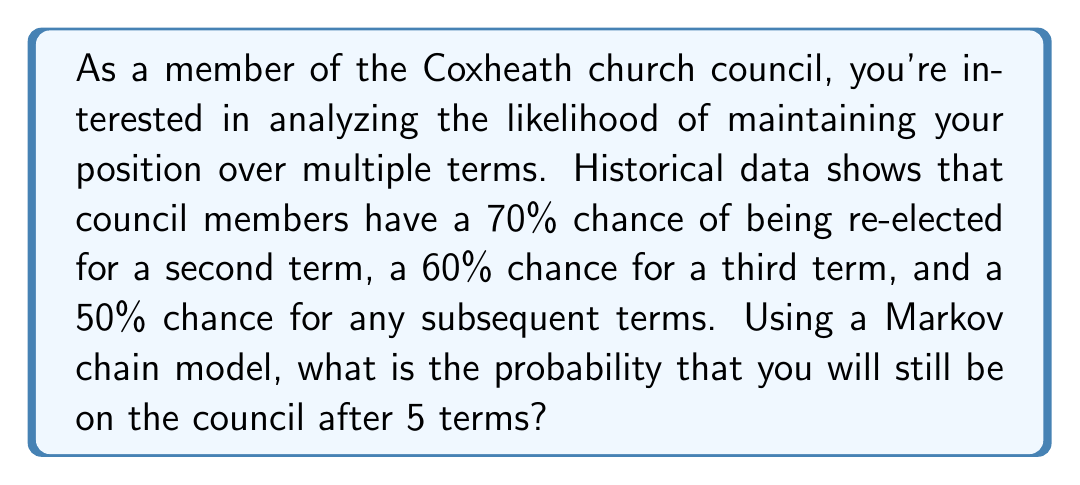Give your solution to this math problem. Let's approach this step-by-step using a Markov chain:

1) First, let's define our states:
   State 1: On the council
   State 2: Off the council (absorbing state)

2) We can represent our Markov chain with the following transition matrix:

   $$P = \begin{bmatrix}
   p_{11} & p_{12} \\
   0 & 1
   \end{bmatrix}$$

   Where $p_{11}$ is the probability of staying on the council, and $p_{12}$ is the probability of leaving the council.

3) Given the information:
   - For the 1st to 2nd term: $p_{11} = 0.7$, $p_{12} = 0.3$
   - For the 2nd to 3rd term: $p_{11} = 0.6$, $p_{12} = 0.4$
   - For subsequent terms: $p_{11} = 0.5$, $p_{12} = 0.5$

4) To calculate the probability of being on the council after 5 terms, we need to multiply these probabilities:

   $$P(\text{on council after 5 terms}) = 0.7 \times 0.6 \times 0.5 \times 0.5 \times 0.5$$

5) Let's calculate:
   $$0.7 \times 0.6 = 0.42$$
   $$0.42 \times 0.5 = 0.21$$
   $$0.21 \times 0.5 = 0.105$$
   $$0.105 \times 0.5 = 0.0525$$

Thus, the probability of still being on the council after 5 terms is 0.0525 or 5.25%.
Answer: 0.0525 